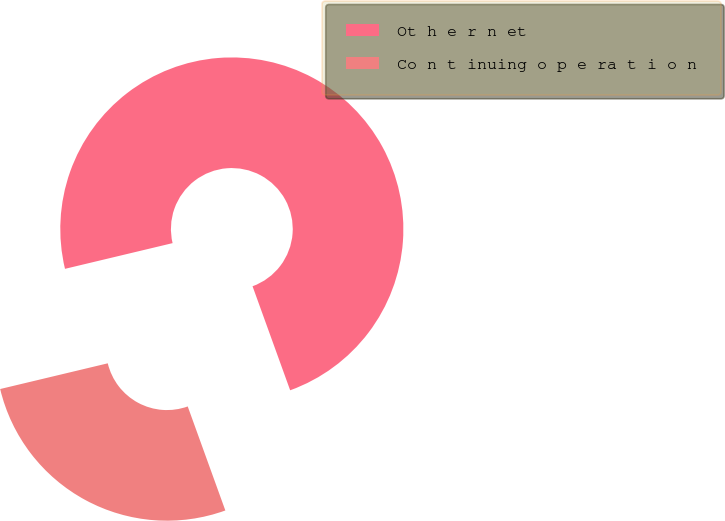Convert chart to OTSL. <chart><loc_0><loc_0><loc_500><loc_500><pie_chart><fcel>Ot h e r n et<fcel>Co n t inuing o p e ra t i o n<nl><fcel>73.21%<fcel>26.79%<nl></chart> 